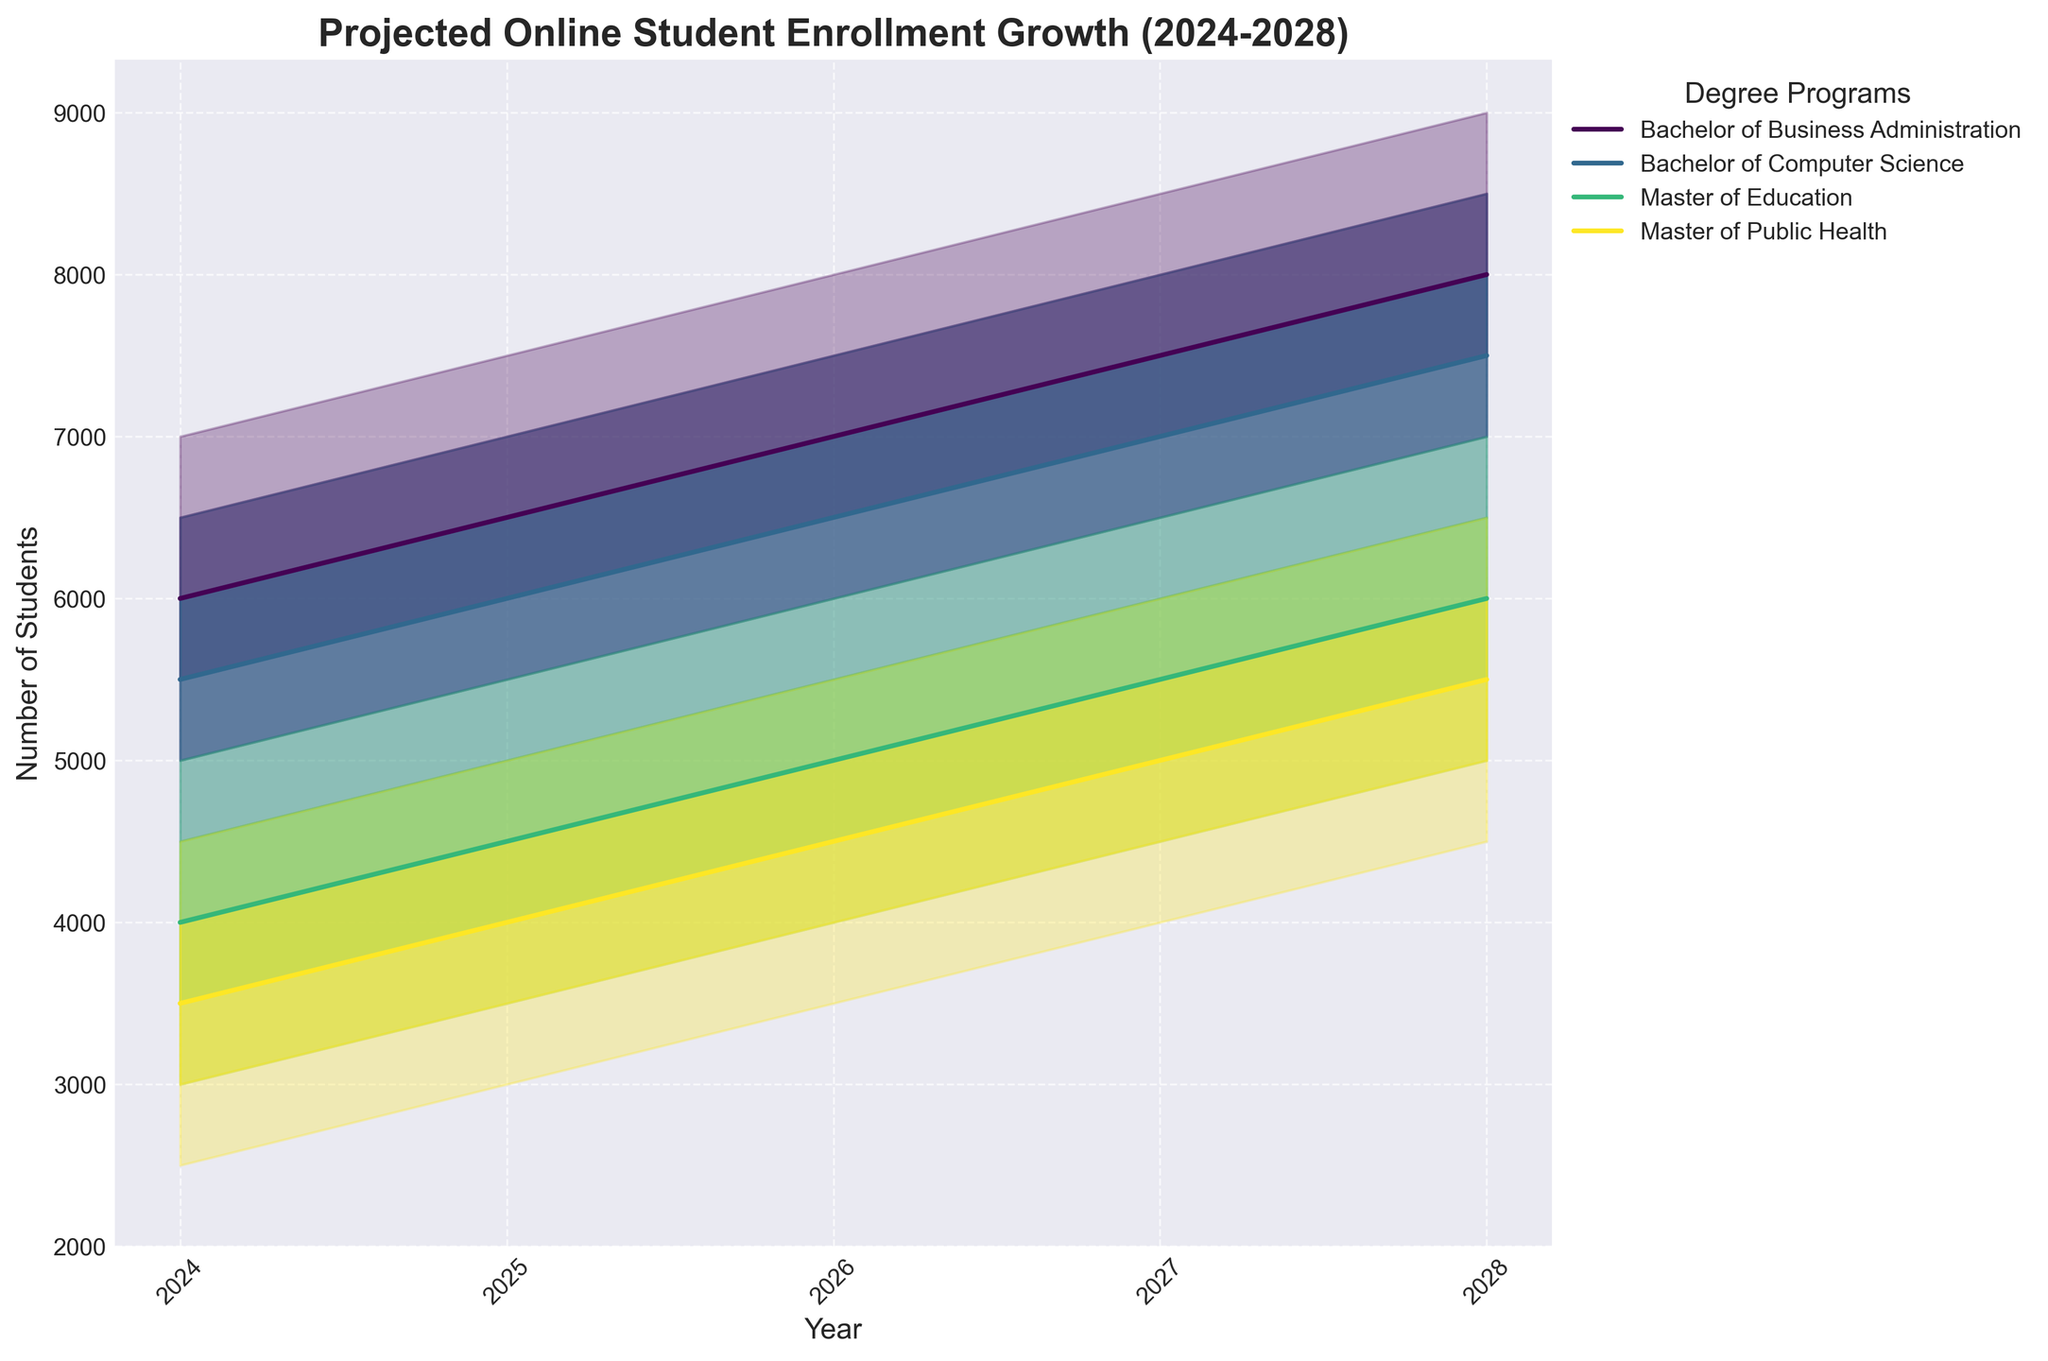What year has the highest projected midpoint enrollment for the Bachelor of Computer Science program? To find this, look at the "Mid" line specific to the Bachelor of Computer Science program and identify the year with the highest value. For the Bachelor of Computer Science, the projected midpoint enrollment grows every year from 2024 to 2028, reaching its highest value in 2028.
Answer: 2028 What is the range of projected enrollment for the Master of Public Health program in 2024? To determine this, look at the lower and upper bounds for the Master of Public Health program in 2024. The lowest projection ("Low") is 2500 students, and the highest projection ("High") is 4500 students, resulting in a range of 4500 - 2500 = 2000.
Answer: 2000 Which degree program shows the greatest increase in the midpoint projection from 2024 to 2028? Calculate the difference between the midpoint values for 2024 and 2028 for each program. 
- Bachelor of Business Administration: 8000 - 6000 = 2000
- Bachelor of Computer Science: 7500 - 5500 = 2000
- Master of Education: 6000 - 4000 = 2000
- Master of Public Health: 5500 - 3500 = 2000
All programs show the same increase in midpoint enrollment from 2024 to 2028.
Answer: All programs How does the 2028 high enrollment projection for the Master of Education compare to the 2024 high projection for the same program? Look at the "High" projection value for the Master of Education program in both 2028 and 2024.
- In 2024, the high projection is 5000 students.
- In 2028, the high projection is 7000 students.
Then, calculate the difference: 7000 - 5000 = 2000. The 2028 high projection is 2000 students higher.
Answer: 2000 higher What is the spread of enrollment predictions (difference between 'High' and 'Low') for the Bachelor of Business Administration in 2027? Identify the 'High' and 'Low' values for 2027 for the Bachelor of Business Administration.
- High: 8500
- Low: 6500
Calculate the spread: 8500 - 6500 = 2000.
Answer: 2000 Which degree program has the smallest range of predictions in 2025 (difference between 'High' and 'Low')? Calculate the range for each program in 2025 by subtracting the 'Low' from the 'High' value.
- Bachelor of Business Administration: 7500 - 5500 = 2000
- Bachelor of Computer Science: 7000 - 5000 = 2000
- Master of Education: 5500 - 3500 = 2000
- Master of Public Health: 5000 - 3000 = 2000
All programs have the same range of predictions in 2025.
Answer: All programs Which program is projected to cross 5000 students in its midpoint enrollment the earliest? Review the 'Year' and 'Mid' values for each program to see when they exceed 5000 students:
- Bachelor of Business Administration: 2024 (6000)
- Bachelor of Computer Science: 2024 (5500)
- Master of Education: Does not meet criterion by 2028
- Master of Public Health: 2028 (5500)
The Bachelor of Business Administration and Bachelor of Computer Science both cross 5000 students in 2024.
Answer: Bachelor of Business Administration and Bachelor of Computer Science In 2026, which two degree programs have the closest midpoint enrollment projections, and what are their values? Look at the midpoint values for all programs in 2026:
- Bachelor of Business Administration: 7000
- Bachelor of Computer Science: 6500
- Master of Education: 5000
- Master of Public Health: 4500
Calculate the differences to find the closest pair: 
- The Bachelor of Business Administration (7000) and Bachelor of Computer Science (6500) differ by 500, which is the smallest difference between any two programs.
Answer: Bachelor of Business Administration (7000) and Bachelor of Computer Science (6500) What is the total midpoint enrollment projected across all programs in 2028? Sum the midpoint values for all programs in 2028:
- Bachelor of Business Administration: 8000
- Bachelor of Computer Science: 7500
- Master of Education: 6000
- Master of Public Health: 5500
Total = 8000 + 7500 + 6000 + 5500 = 27000.
Answer: 27000 